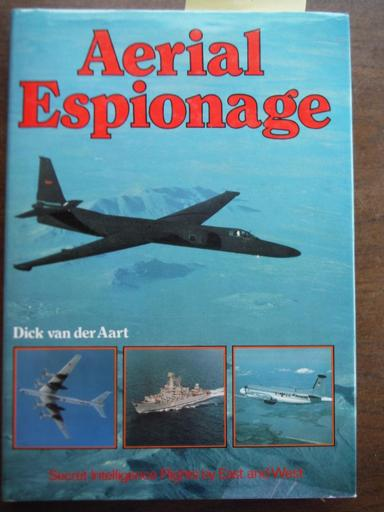What is the subject of the book? The book 'Aerial Espionage' delves into the intriguing world of secret intelligence flights conducted by both Eastern and Western forces. It explores detailed accounts and provides visual documentation of various military aircraft, highlighting their roles in the nuanced art of espionage from the air. 